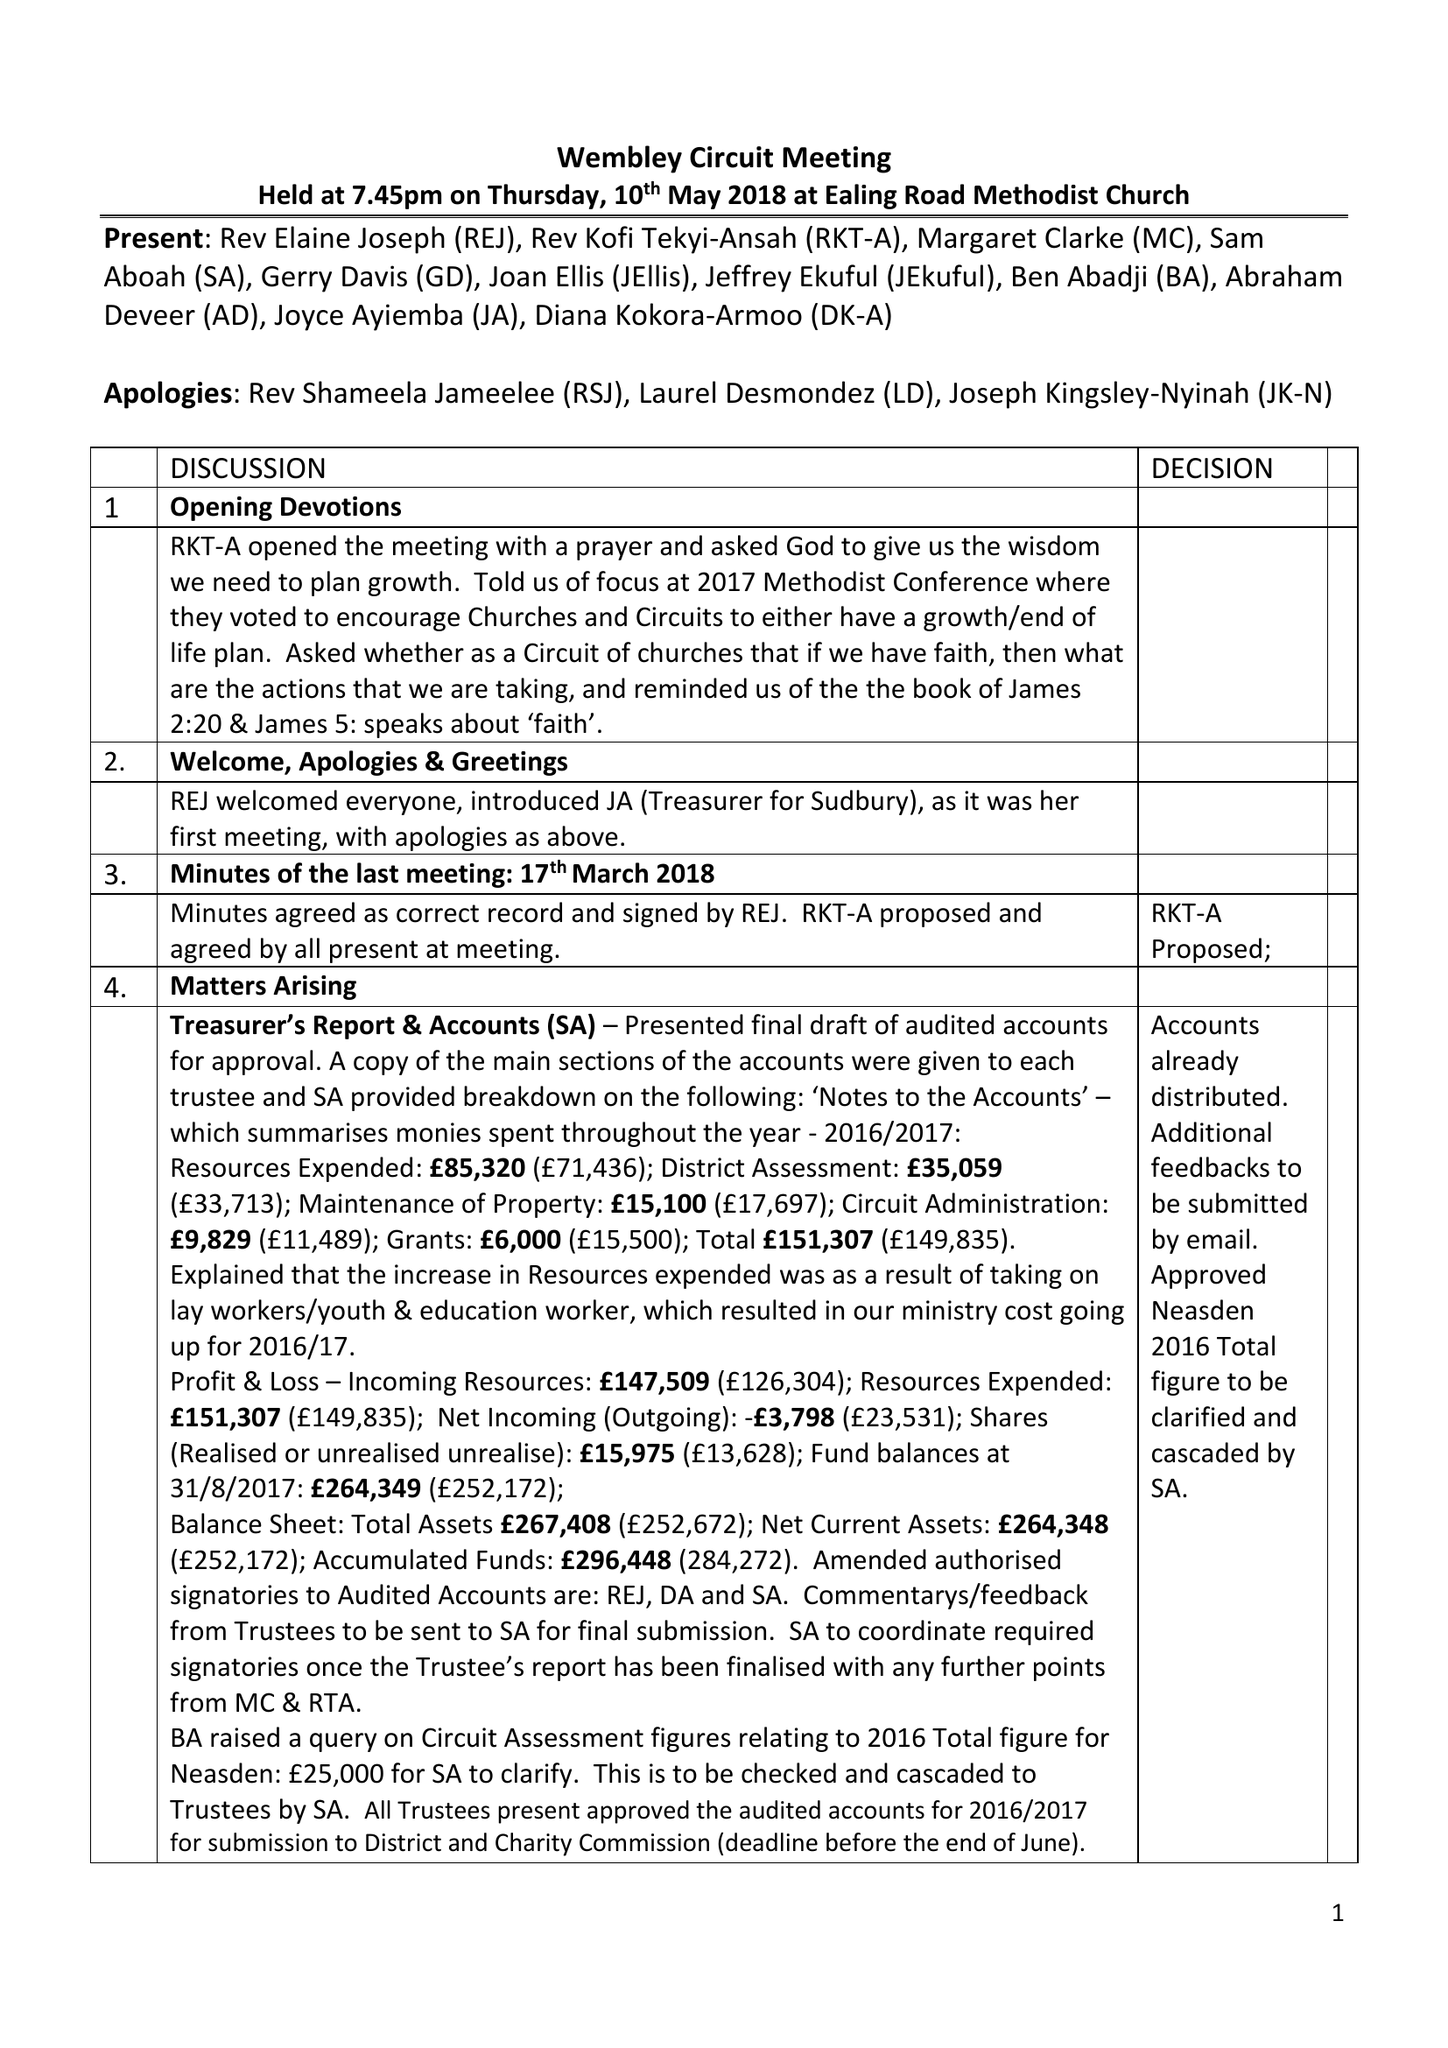What is the value for the spending_annually_in_british_pounds?
Answer the question using a single word or phrase. 151307.00 